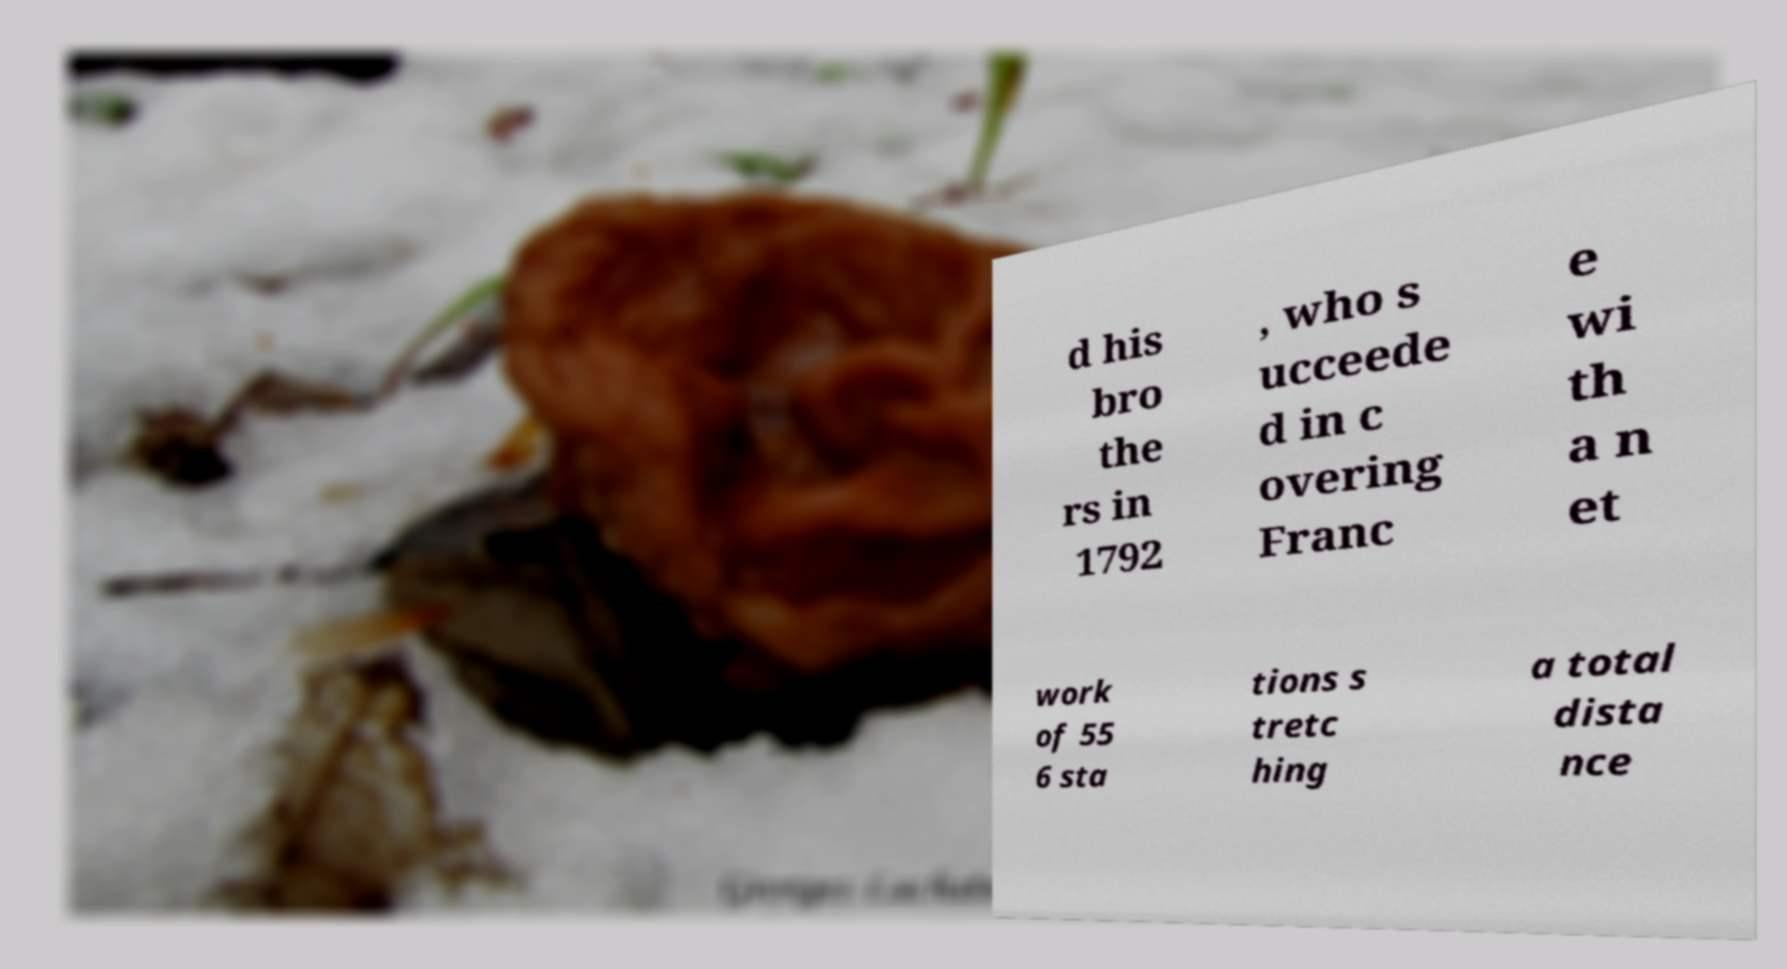What messages or text are displayed in this image? I need them in a readable, typed format. d his bro the rs in 1792 , who s ucceede d in c overing Franc e wi th a n et work of 55 6 sta tions s tretc hing a total dista nce 